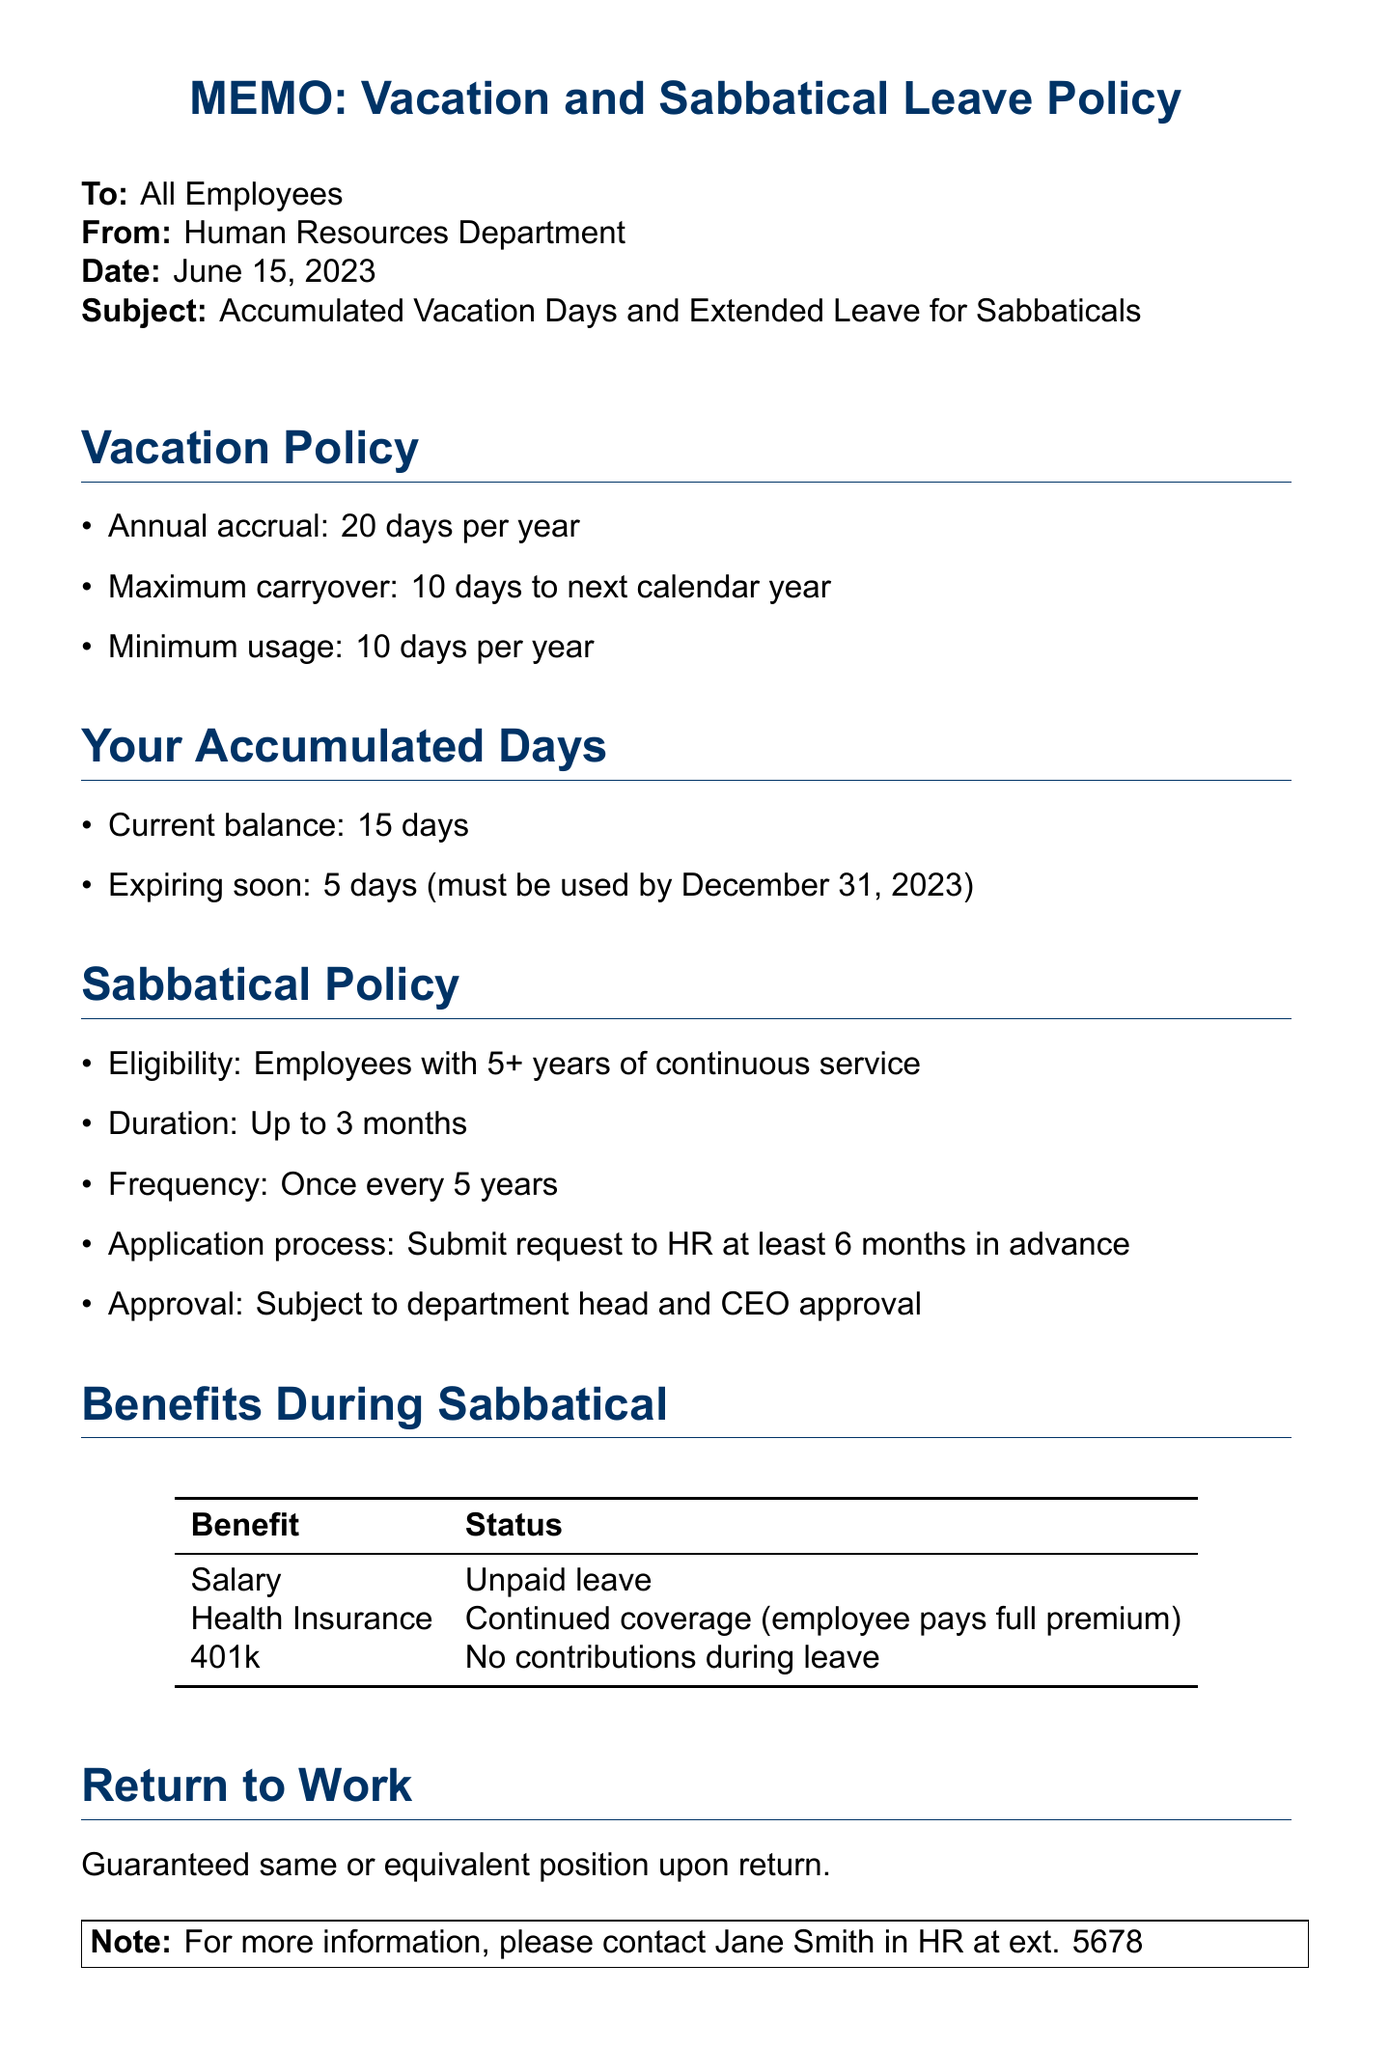What is the annual vacation days accrual? The document states that employees accrue 20 days of vacation per year.
Answer: 20 days What is the current balance of accumulated vacation days? According to the document, the current balance of accumulated vacation days is 15 days.
Answer: 15 days How many vacation days must be used by December 31, 2023? The document specifies that 5 days must be used by December 31, 2023.
Answer: 5 days What is the minimum vacation day usage per year? The minimum usage required per year is stated in the document as 10 days.
Answer: 10 days What is the maximum number of days that can be carried over to the next year? The document indicates that a maximum of 10 days can be carried over to the next calendar year.
Answer: 10 days How long can a sabbatical last? The document explains that a sabbatical can last up to 3 months.
Answer: 3 months What is the eligibility requirement for a sabbatical? The eligibility requirement stated in the document is employees having 5 or more years of continuous service.
Answer: 5+ years Is salary paid during a sabbatical? The document notes that the salary during a sabbatical is unpaid leave.
Answer: Unpaid Who should requests for a sabbatical be submitted to? Requests for a sabbatical should be submitted to HR, as stated in the document.
Answer: HR When should the sabbatical request be submitted? The document specifies that the sabbatical request should be submitted at least 6 months in advance.
Answer: 6 months 